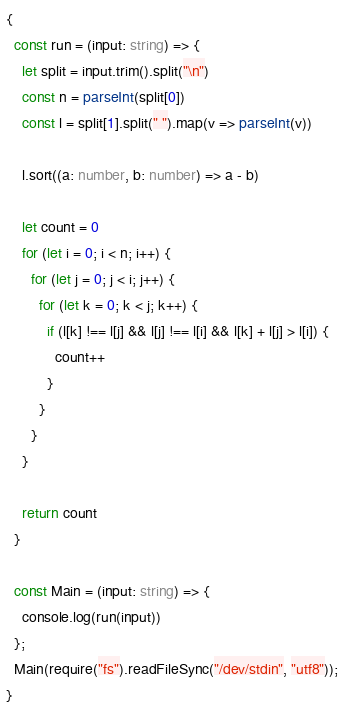<code> <loc_0><loc_0><loc_500><loc_500><_TypeScript_>{
  const run = (input: string) => {
    let split = input.trim().split("\n")
    const n = parseInt(split[0])
    const l = split[1].split(" ").map(v => parseInt(v))

    l.sort((a: number, b: number) => a - b)

    let count = 0
    for (let i = 0; i < n; i++) {
      for (let j = 0; j < i; j++) {
        for (let k = 0; k < j; k++) {
          if (l[k] !== l[j] && l[j] !== l[i] && l[k] + l[j] > l[i]) {
            count++
          }
        }
      }
    }

    return count
  }

  const Main = (input: string) => {
    console.log(run(input))
  };
  Main(require("fs").readFileSync("/dev/stdin", "utf8"));
}
</code> 